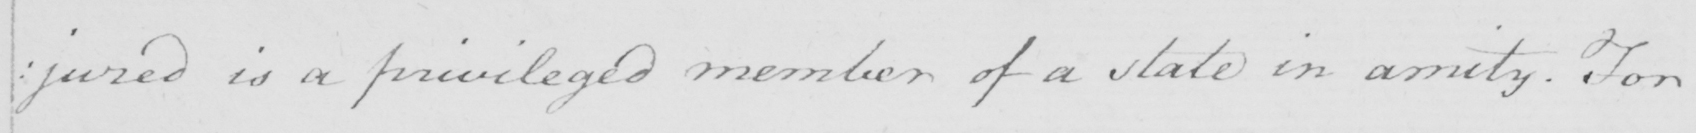Please transcribe the handwritten text in this image. : jured is a privileged member of a state in amity . For 